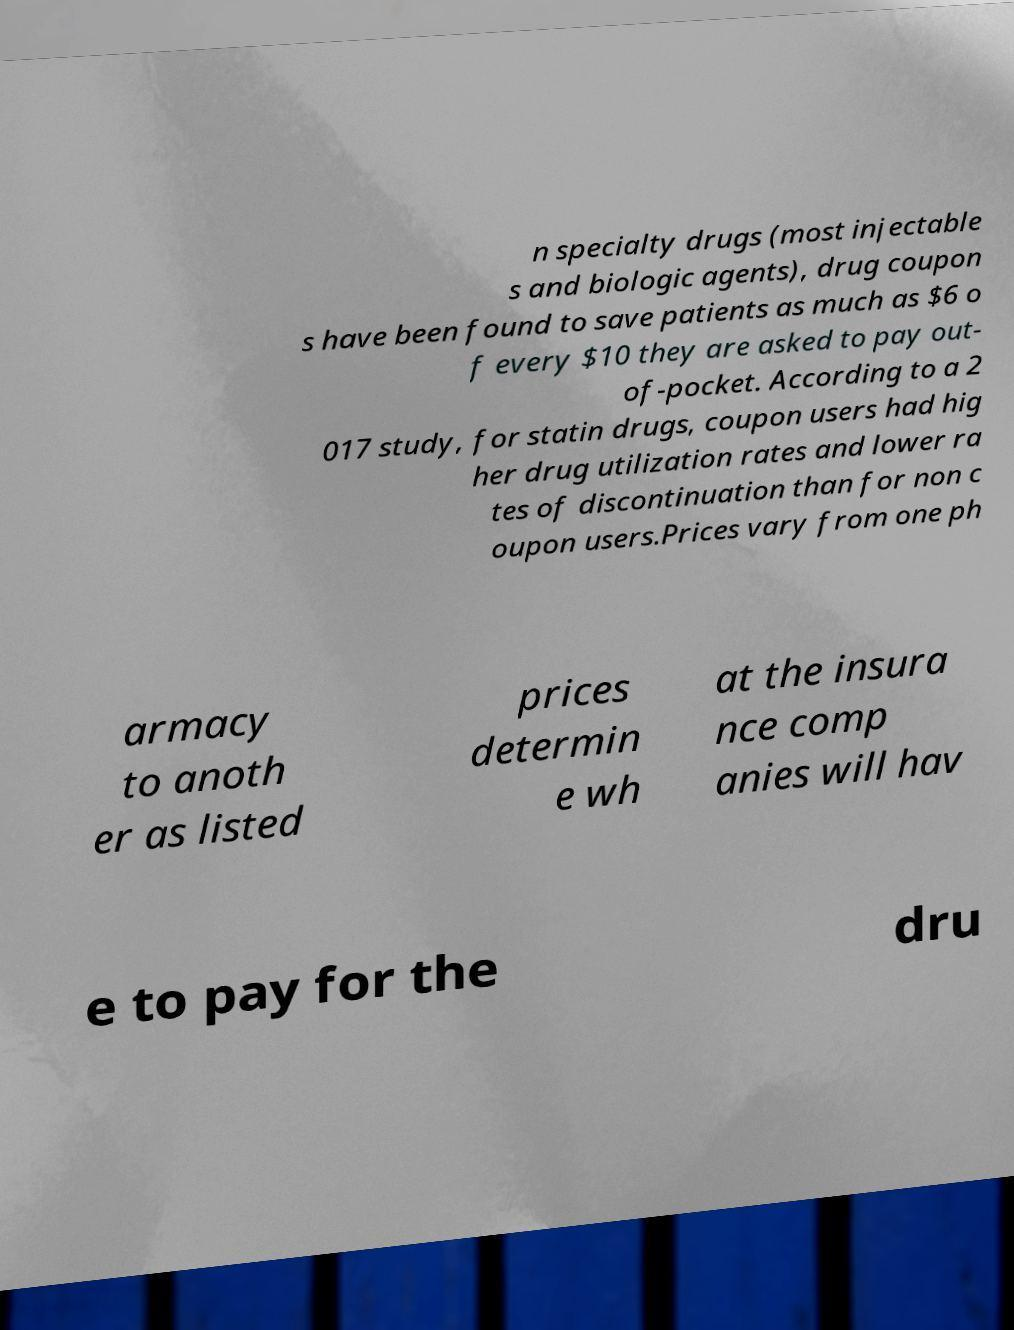I need the written content from this picture converted into text. Can you do that? n specialty drugs (most injectable s and biologic agents), drug coupon s have been found to save patients as much as $6 o f every $10 they are asked to pay out- of-pocket. According to a 2 017 study, for statin drugs, coupon users had hig her drug utilization rates and lower ra tes of discontinuation than for non c oupon users.Prices vary from one ph armacy to anoth er as listed prices determin e wh at the insura nce comp anies will hav e to pay for the dru 